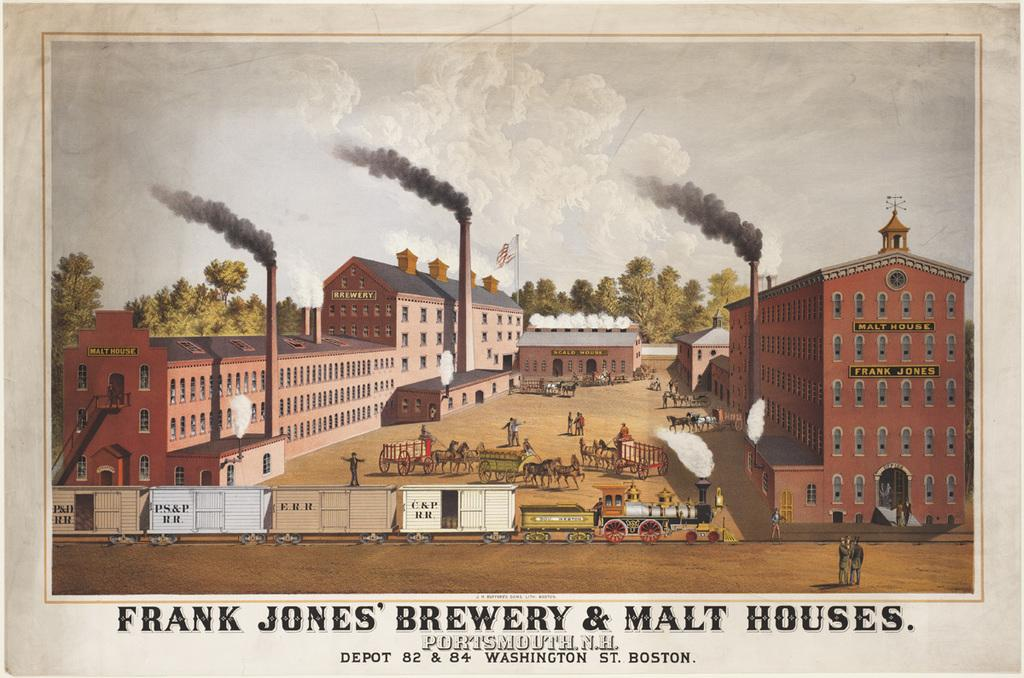<image>
Summarize the visual content of the image. A poster shows a factory complex; the caption reads "Frank Jones' Brewery & Malt House". 